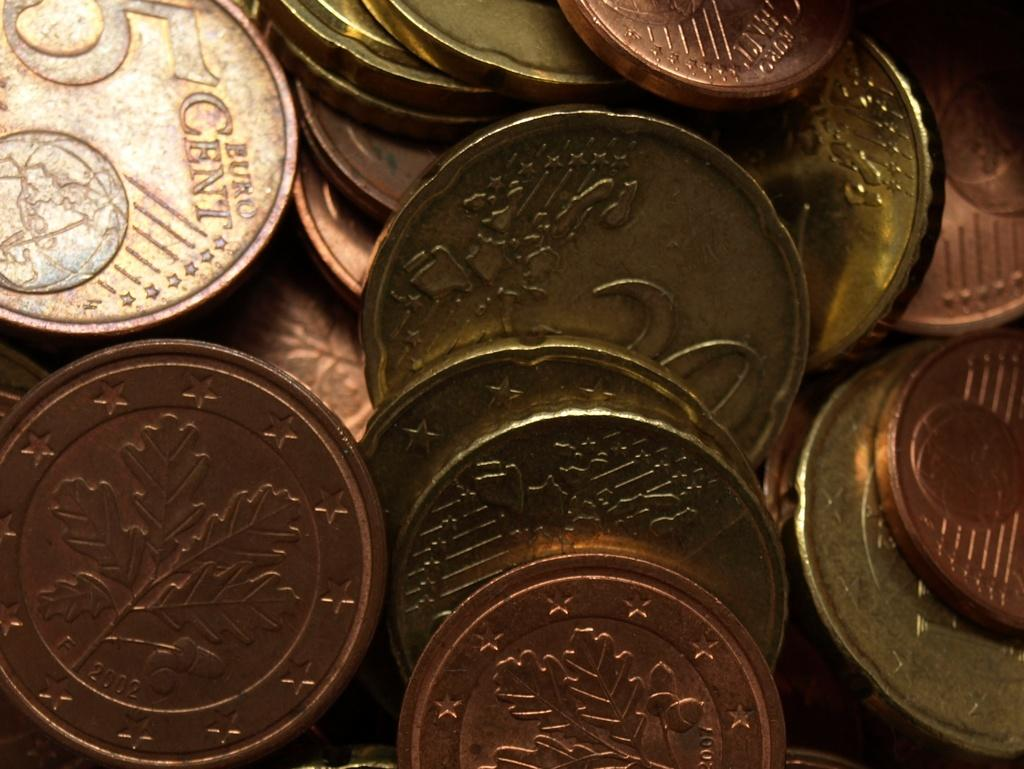<image>
Share a concise interpretation of the image provided. Copper and gold coins with euro cent printed on it. 